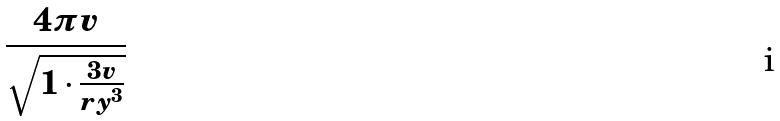<formula> <loc_0><loc_0><loc_500><loc_500>\frac { 4 \pi v } { \sqrt { 1 \cdot \frac { 3 v } { r y ^ { 3 } } } }</formula> 